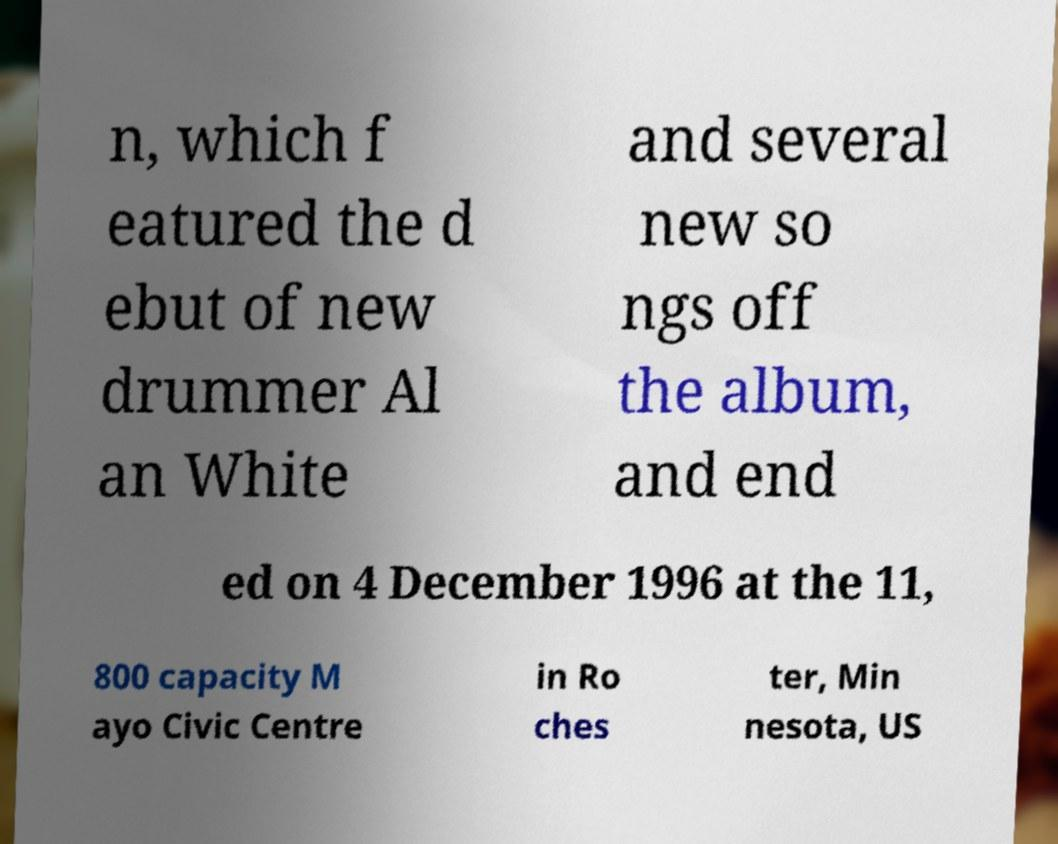There's text embedded in this image that I need extracted. Can you transcribe it verbatim? n, which f eatured the d ebut of new drummer Al an White and several new so ngs off the album, and end ed on 4 December 1996 at the 11, 800 capacity M ayo Civic Centre in Ro ches ter, Min nesota, US 